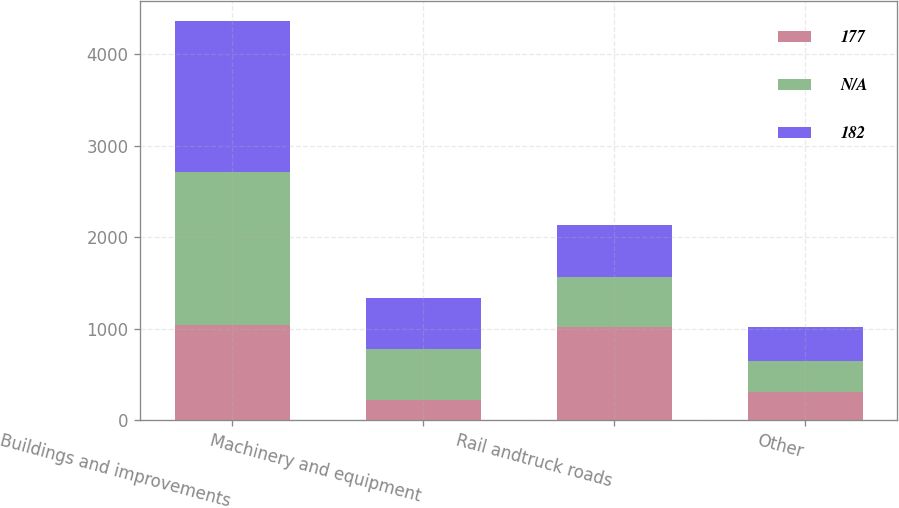<chart> <loc_0><loc_0><loc_500><loc_500><stacked_bar_chart><ecel><fcel>Buildings and improvements<fcel>Machinery and equipment<fcel>Rail andtruck roads<fcel>Other<nl><fcel>177<fcel>1040<fcel>225<fcel>1020<fcel>310<nl><fcel>nan<fcel>1677<fcel>554.5<fcel>547<fcel>334<nl><fcel>182<fcel>1643<fcel>554.5<fcel>562<fcel>381<nl></chart> 